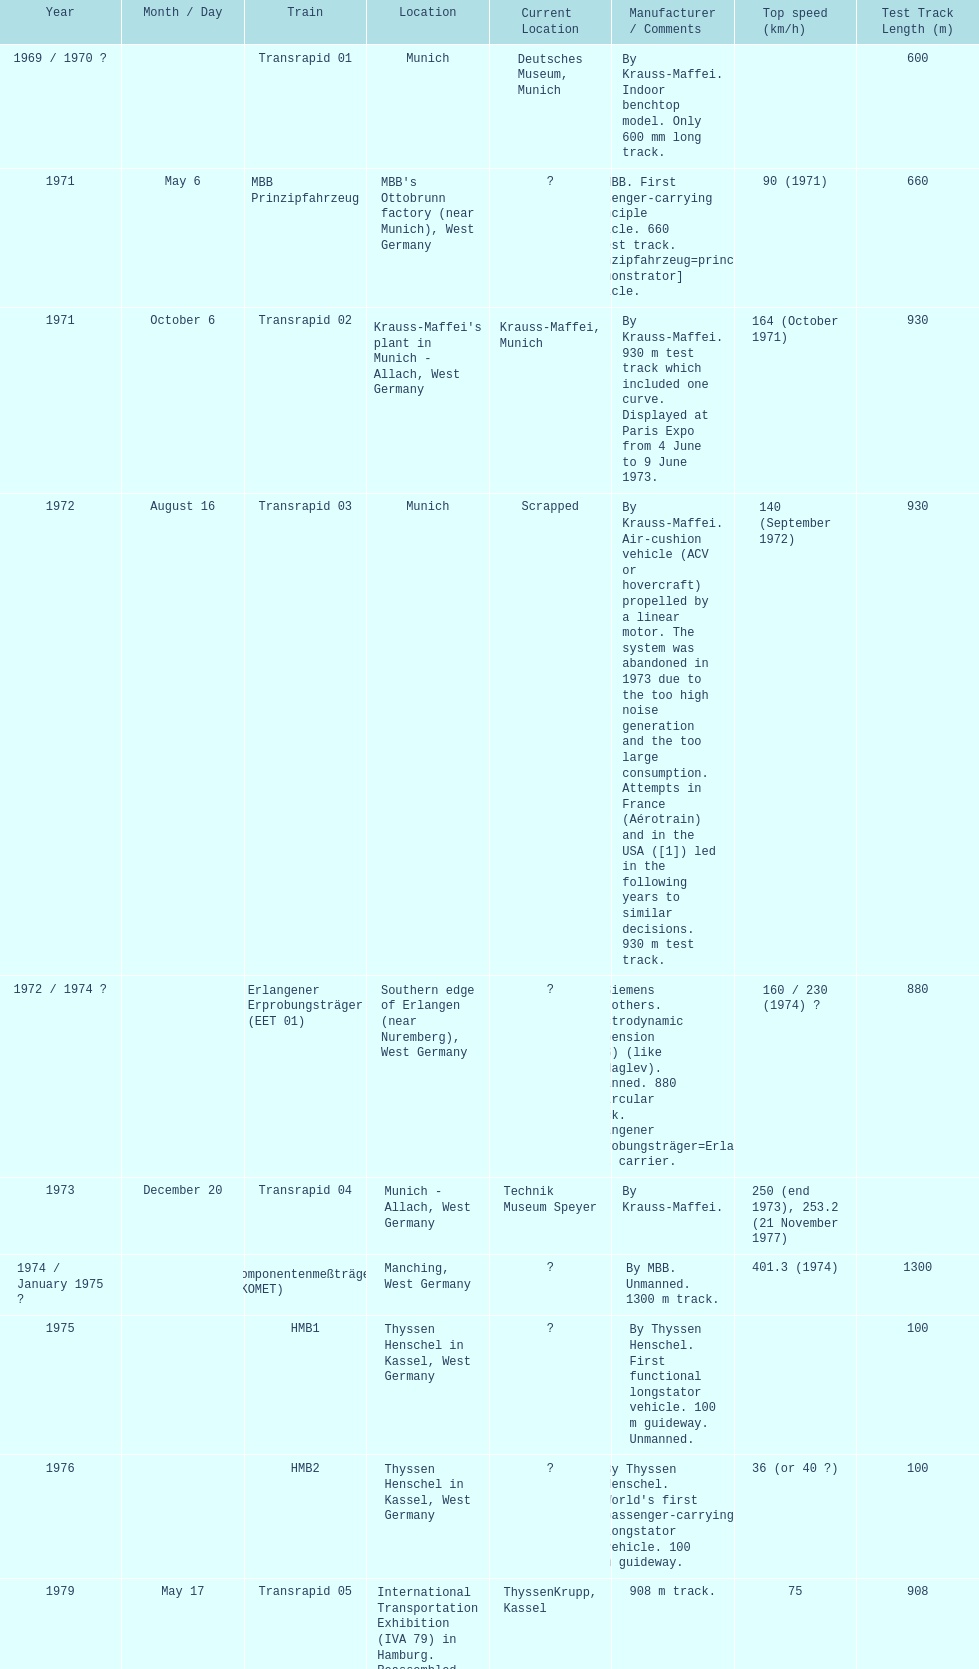How many trains listed have the same speed as the hmb2? 0. 